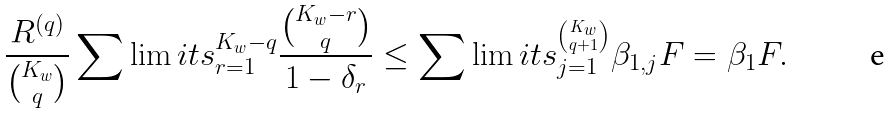<formula> <loc_0><loc_0><loc_500><loc_500>\frac { { { { R } ^ { ( q ) } } } } { { \binom { K _ { w } } { q } } } \sum \lim i t s _ { r = 1 } ^ { { K _ { w } } - q } { \frac { { \binom { { K _ { w } } - r } { q } } } { { 1 - { \delta _ { r } } } } } \leq \sum \lim i t s _ { j = 1 } ^ { \binom { K _ { w } } { q + 1 } } { { { \beta } _ { 1 , j } } } F = { { \beta } _ { 1 } } F .</formula> 